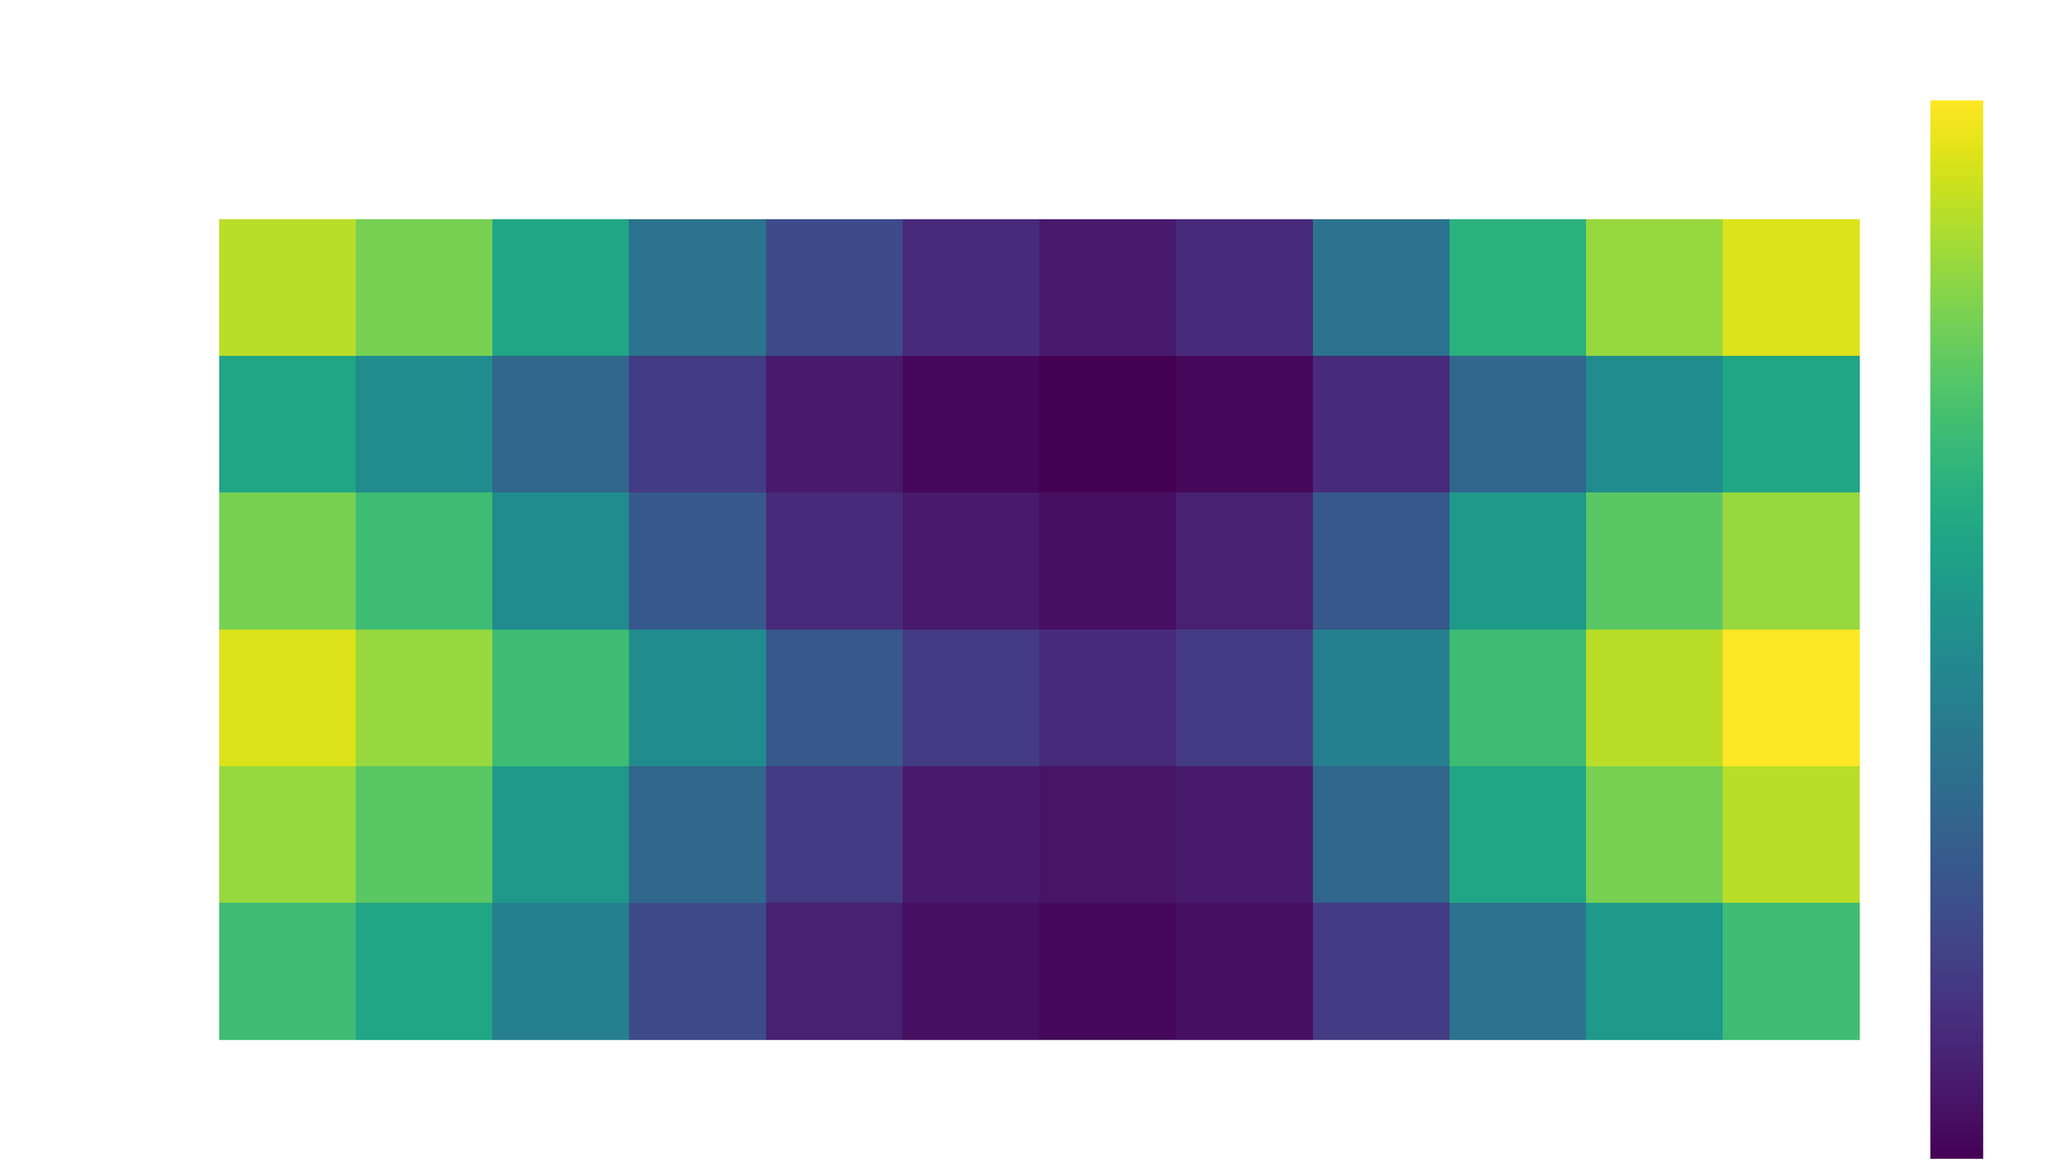What is the foggiest month in London? Look at the heatmap for the region "London" and identify the month with the highest fog density value. The darkest color in December indicates the highest fog density.
Answer: December Which region has the lowest fog density in July? Identify the regions along the y-axis and observe their fog density values for July. The faintest color corresponds to Bristol, indicating the lowest density.
Answer: Bristol How does the fog density in November compare between Sheffield and Liverpool? Compare the colors for Sheffield and Liverpool in November. Sheffield's color is lighter than Liverpool's, indicating that Sheffield has a lower fog density.
Answer: Liverpool has higher fog density What is the average fog density across all regions in March? Find the fog density values for all regions in March: London (70), Birmingham (60), Manchester (55), Liverpool (50), Bristol (35), Sheffield (45). Sum these values (70+60+55+50+35+45=315) and divide by the number of regions (6).
Answer: 52.5 Which region shows the most significant reduction in fog density from January to February? Check the January and February values for each region and calculate the difference. The difference for each region is:
- London: 95 - 85 = 10
- Birmingham: 90 - 80 = 10
- Manchester: 85 - 75 = 10
- Liverpool: 80 - 70 = 10
- Bristol: 60 - 50 = 10
- Sheffield: 70 - 60 = 10
All regions have the same reduction.
Answer: All regions with 10 Which month has the consistently lowest fog density across all regions? Examine the fog density values for each region across all months and identify the month with the lowest overall values. July generally has the faintest colors across most regions.
Answer: July What is the total fog density for Bristol from May to August? Add the fog density values for Bristol from May (10), June (5), July (3), and August (5). Summing these values (10+5+3+5) = 23.
Answer: 23 Is the fog density in October higher in Birmingham or Manchester? Compare the heatmap colors for Birmingham and Manchester in October. Birmingham's color is slightly darker, indicating a higher fog density.
Answer: Birmingham Which region shows a significant spike in fog density in November compared to October? Compare the values in October and November for all regions:
- London: 70 to 90 (20 increase)
- Birmingham: 65 to 85 (20 increase)
- Manchester: 60 to 80 (20 increase)
- Liverpool: 55 to 75 (20 increase)
- Bristol: 35 to 50 (15 increase)
- Sheffield: 40 to 55 (15 increase)
All tend to increase similarly by about 20, but London reaches a peak.
Answer: London In which region is the fog density highest in December, and how does it compare to November in the same region? London has the darkest color in December, indicating the highest fog density. The fog density decreases slightly from December (100) to November (90) in London.
Answer: London, higher in December 